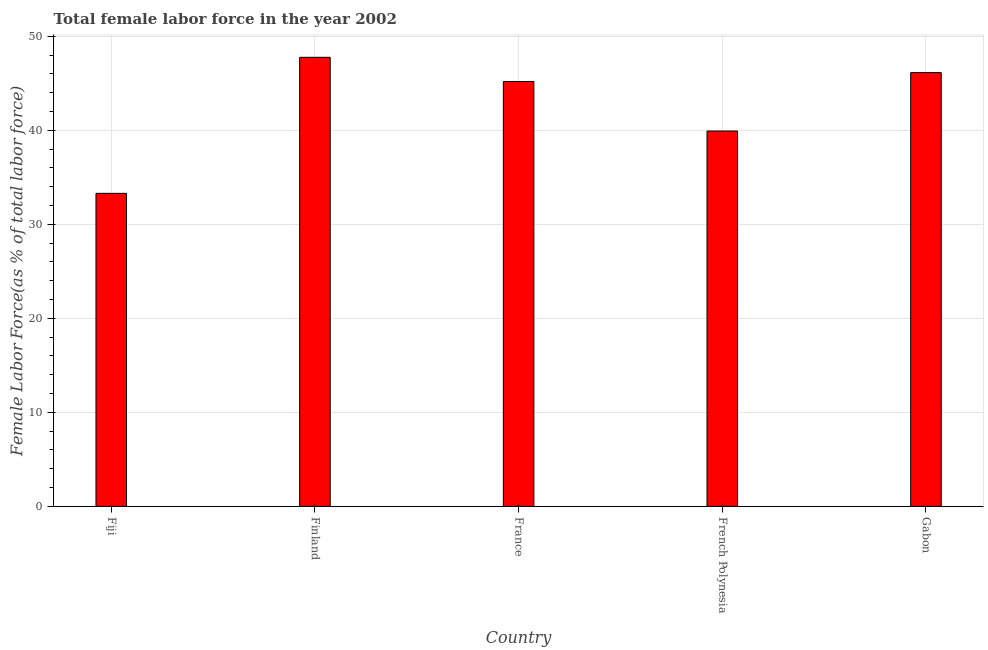Does the graph contain any zero values?
Your answer should be very brief. No. What is the title of the graph?
Offer a very short reply. Total female labor force in the year 2002. What is the label or title of the Y-axis?
Make the answer very short. Female Labor Force(as % of total labor force). What is the total female labor force in Finland?
Your answer should be very brief. 47.77. Across all countries, what is the maximum total female labor force?
Provide a succinct answer. 47.77. Across all countries, what is the minimum total female labor force?
Keep it short and to the point. 33.3. In which country was the total female labor force maximum?
Provide a short and direct response. Finland. In which country was the total female labor force minimum?
Your answer should be compact. Fiji. What is the sum of the total female labor force?
Keep it short and to the point. 212.33. What is the difference between the total female labor force in France and French Polynesia?
Your response must be concise. 5.27. What is the average total female labor force per country?
Provide a short and direct response. 42.47. What is the median total female labor force?
Your answer should be compact. 45.2. What is the ratio of the total female labor force in Fiji to that in Finland?
Provide a short and direct response. 0.7. Is the total female labor force in Finland less than that in French Polynesia?
Ensure brevity in your answer.  No. Is the difference between the total female labor force in Fiji and Finland greater than the difference between any two countries?
Ensure brevity in your answer.  Yes. What is the difference between the highest and the second highest total female labor force?
Provide a short and direct response. 1.63. What is the difference between the highest and the lowest total female labor force?
Offer a terse response. 14.47. What is the Female Labor Force(as % of total labor force) of Fiji?
Your response must be concise. 33.3. What is the Female Labor Force(as % of total labor force) in Finland?
Ensure brevity in your answer.  47.77. What is the Female Labor Force(as % of total labor force) of France?
Keep it short and to the point. 45.2. What is the Female Labor Force(as % of total labor force) of French Polynesia?
Your response must be concise. 39.93. What is the Female Labor Force(as % of total labor force) of Gabon?
Your answer should be compact. 46.14. What is the difference between the Female Labor Force(as % of total labor force) in Fiji and Finland?
Your answer should be compact. -14.47. What is the difference between the Female Labor Force(as % of total labor force) in Fiji and France?
Your response must be concise. -11.9. What is the difference between the Female Labor Force(as % of total labor force) in Fiji and French Polynesia?
Give a very brief answer. -6.63. What is the difference between the Female Labor Force(as % of total labor force) in Fiji and Gabon?
Ensure brevity in your answer.  -12.84. What is the difference between the Female Labor Force(as % of total labor force) in Finland and France?
Make the answer very short. 2.57. What is the difference between the Female Labor Force(as % of total labor force) in Finland and French Polynesia?
Provide a succinct answer. 7.84. What is the difference between the Female Labor Force(as % of total labor force) in Finland and Gabon?
Ensure brevity in your answer.  1.63. What is the difference between the Female Labor Force(as % of total labor force) in France and French Polynesia?
Make the answer very short. 5.27. What is the difference between the Female Labor Force(as % of total labor force) in France and Gabon?
Your answer should be very brief. -0.94. What is the difference between the Female Labor Force(as % of total labor force) in French Polynesia and Gabon?
Make the answer very short. -6.21. What is the ratio of the Female Labor Force(as % of total labor force) in Fiji to that in Finland?
Give a very brief answer. 0.7. What is the ratio of the Female Labor Force(as % of total labor force) in Fiji to that in France?
Give a very brief answer. 0.74. What is the ratio of the Female Labor Force(as % of total labor force) in Fiji to that in French Polynesia?
Offer a terse response. 0.83. What is the ratio of the Female Labor Force(as % of total labor force) in Fiji to that in Gabon?
Your response must be concise. 0.72. What is the ratio of the Female Labor Force(as % of total labor force) in Finland to that in France?
Give a very brief answer. 1.06. What is the ratio of the Female Labor Force(as % of total labor force) in Finland to that in French Polynesia?
Your response must be concise. 1.2. What is the ratio of the Female Labor Force(as % of total labor force) in Finland to that in Gabon?
Your answer should be very brief. 1.03. What is the ratio of the Female Labor Force(as % of total labor force) in France to that in French Polynesia?
Offer a terse response. 1.13. What is the ratio of the Female Labor Force(as % of total labor force) in French Polynesia to that in Gabon?
Your answer should be compact. 0.86. 